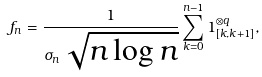Convert formula to latex. <formula><loc_0><loc_0><loc_500><loc_500>f _ { n } = \frac { 1 } { \sigma _ { n } \, \sqrt { n \log n } } \sum _ { k = 0 } ^ { n - 1 } { 1 } _ { [ k , k + 1 ] } ^ { \otimes q } ,</formula> 